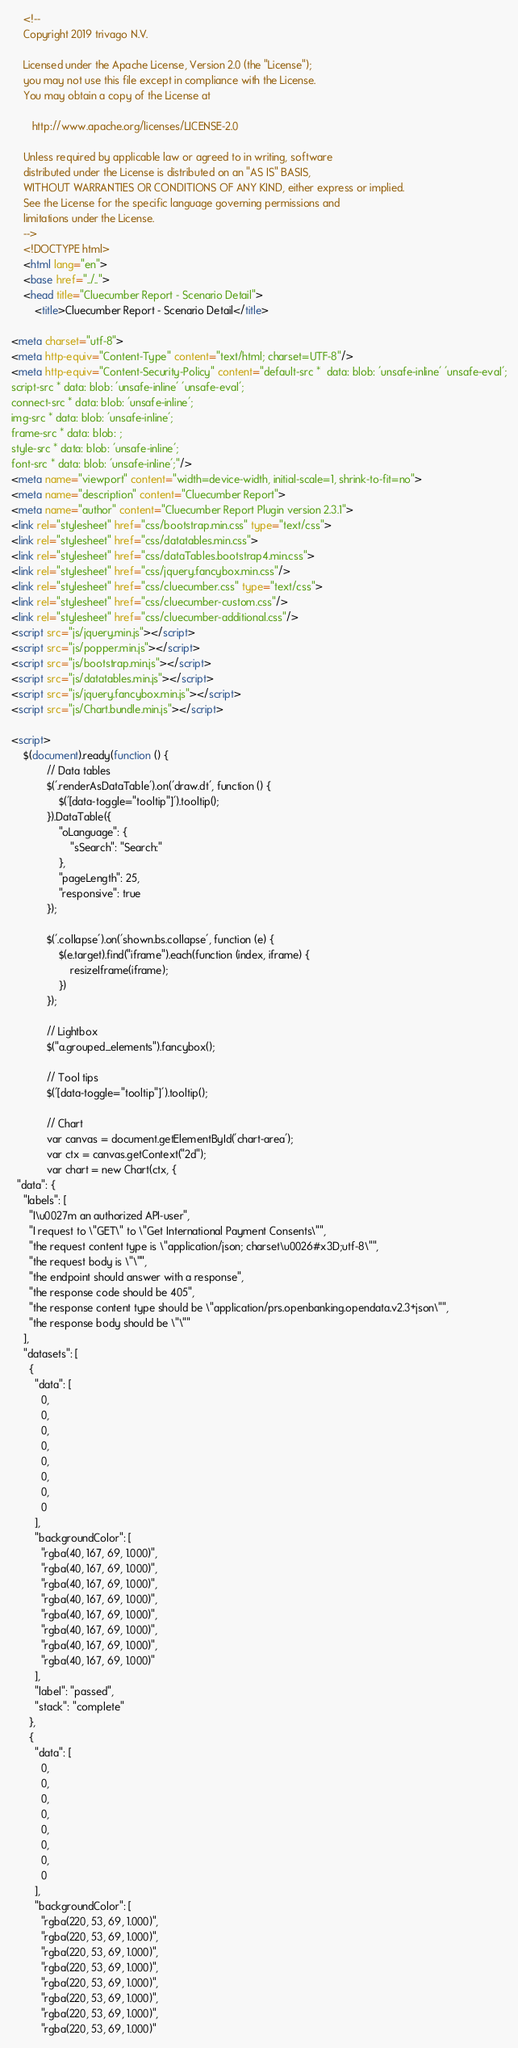<code> <loc_0><loc_0><loc_500><loc_500><_HTML_>
    <!--
    Copyright 2019 trivago N.V.

    Licensed under the Apache License, Version 2.0 (the "License");
    you may not use this file except in compliance with the License.
    You may obtain a copy of the License at

       http://www.apache.org/licenses/LICENSE-2.0

    Unless required by applicable law or agreed to in writing, software
    distributed under the License is distributed on an "AS IS" BASIS,
    WITHOUT WARRANTIES OR CONDITIONS OF ANY KIND, either express or implied.
    See the License for the specific language governing permissions and
    limitations under the License.
    -->
    <!DOCTYPE html>
    <html lang="en">
    <base href="../..">
    <head title="Cluecumber Report - Scenario Detail">
        <title>Cluecumber Report - Scenario Detail</title>

<meta charset="utf-8">
<meta http-equiv="Content-Type" content="text/html; charset=UTF-8"/>
<meta http-equiv="Content-Security-Policy" content="default-src *  data: blob: 'unsafe-inline' 'unsafe-eval';
script-src * data: blob: 'unsafe-inline' 'unsafe-eval';
connect-src * data: blob: 'unsafe-inline';
img-src * data: blob: 'unsafe-inline';
frame-src * data: blob: ;
style-src * data: blob: 'unsafe-inline';
font-src * data: blob: 'unsafe-inline';"/>
<meta name="viewport" content="width=device-width, initial-scale=1, shrink-to-fit=no">
<meta name="description" content="Cluecumber Report">
<meta name="author" content="Cluecumber Report Plugin version 2.3.1">
<link rel="stylesheet" href="css/bootstrap.min.css" type="text/css">
<link rel="stylesheet" href="css/datatables.min.css">
<link rel="stylesheet" href="css/dataTables.bootstrap4.min.css">
<link rel="stylesheet" href="css/jquery.fancybox.min.css"/>
<link rel="stylesheet" href="css/cluecumber.css" type="text/css">
<link rel="stylesheet" href="css/cluecumber-custom.css"/>
<link rel="stylesheet" href="css/cluecumber-additional.css"/>
<script src="js/jquery.min.js"></script>
<script src="js/popper.min.js"></script>
<script src="js/bootstrap.min.js"></script>
<script src="js/datatables.min.js"></script>
<script src="js/jquery.fancybox.min.js"></script>
<script src="js/Chart.bundle.min.js"></script>

<script>
    $(document).ready(function () {
            // Data tables
            $('.renderAsDataTable').on('draw.dt', function () {
                $('[data-toggle="tooltip"]').tooltip();
            }).DataTable({
                "oLanguage": {
                    "sSearch": "Search:"
                },
                "pageLength": 25,
                "responsive": true
            });

            $('.collapse').on('shown.bs.collapse', function (e) {
                $(e.target).find("iframe").each(function (index, iframe) {
                    resizeIframe(iframe);
                })
            });

            // Lightbox
            $("a.grouped_elements").fancybox();

            // Tool tips
            $('[data-toggle="tooltip"]').tooltip();

            // Chart
            var canvas = document.getElementById('chart-area');
            var ctx = canvas.getContext("2d");
            var chart = new Chart(ctx, {
  "data": {
    "labels": [
      "I\u0027m an authorized API-user",
      "I request to \"GET\" to \"Get International Payment Consents\"",
      "the request content type is \"application/json; charset\u0026#x3D;utf-8\"",
      "the request body is \"\"",
      "the endpoint should answer with a response",
      "the response code should be 405",
      "the response content type should be \"application/prs.openbanking.opendata.v2.3+json\"",
      "the response body should be \"\""
    ],
    "datasets": [
      {
        "data": [
          0,
          0,
          0,
          0,
          0,
          0,
          0,
          0
        ],
        "backgroundColor": [
          "rgba(40, 167, 69, 1.000)",
          "rgba(40, 167, 69, 1.000)",
          "rgba(40, 167, 69, 1.000)",
          "rgba(40, 167, 69, 1.000)",
          "rgba(40, 167, 69, 1.000)",
          "rgba(40, 167, 69, 1.000)",
          "rgba(40, 167, 69, 1.000)",
          "rgba(40, 167, 69, 1.000)"
        ],
        "label": "passed",
        "stack": "complete"
      },
      {
        "data": [
          0,
          0,
          0,
          0,
          0,
          0,
          0,
          0
        ],
        "backgroundColor": [
          "rgba(220, 53, 69, 1.000)",
          "rgba(220, 53, 69, 1.000)",
          "rgba(220, 53, 69, 1.000)",
          "rgba(220, 53, 69, 1.000)",
          "rgba(220, 53, 69, 1.000)",
          "rgba(220, 53, 69, 1.000)",
          "rgba(220, 53, 69, 1.000)",
          "rgba(220, 53, 69, 1.000)"</code> 